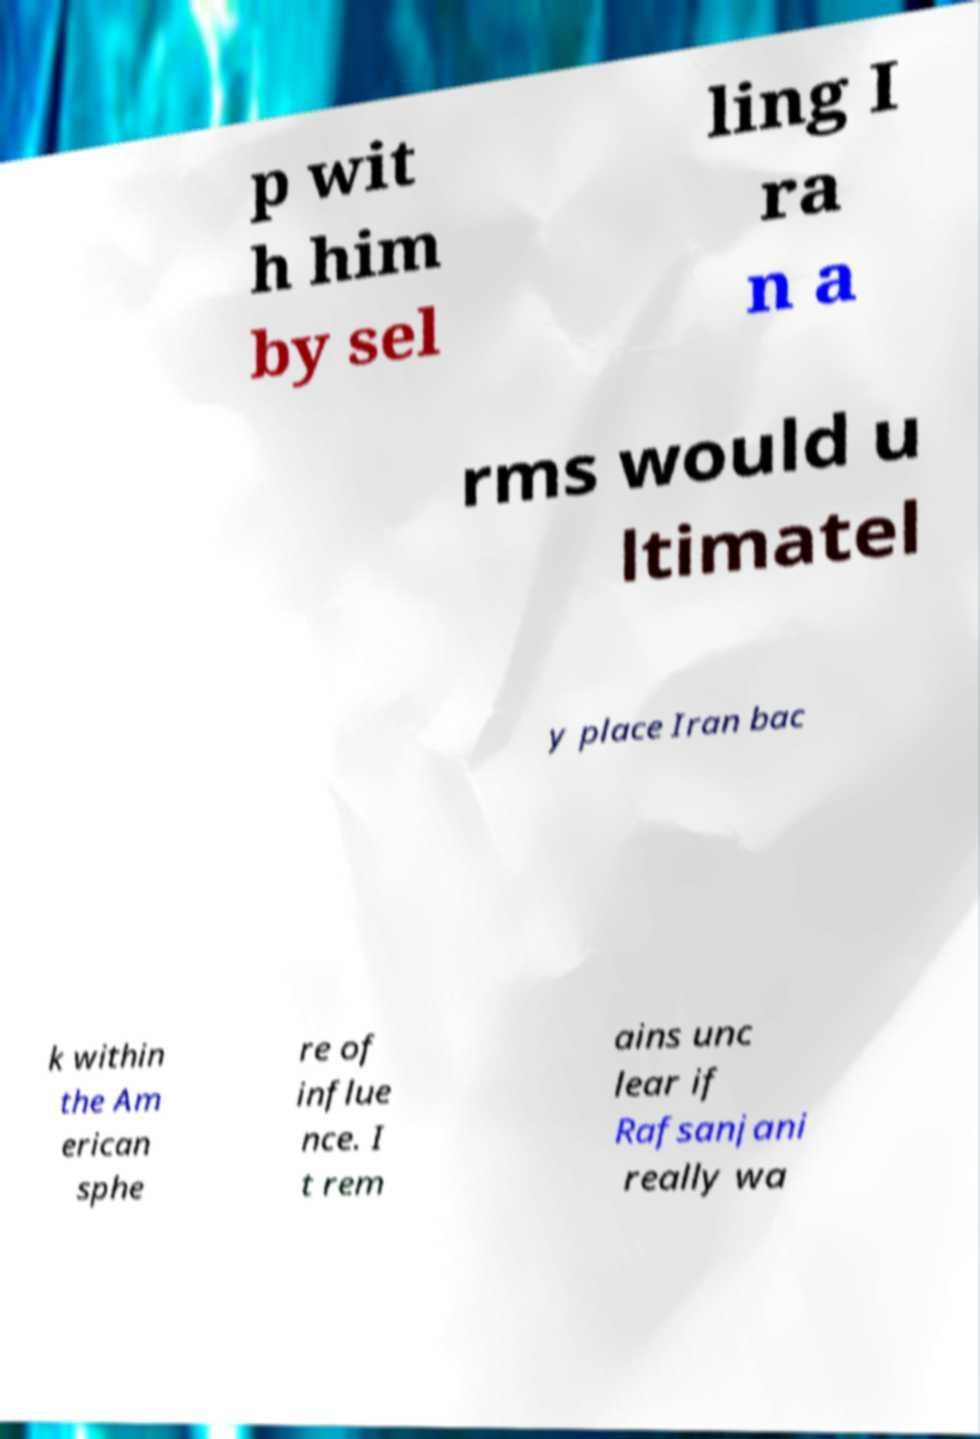Can you read and provide the text displayed in the image?This photo seems to have some interesting text. Can you extract and type it out for me? p wit h him by sel ling I ra n a rms would u ltimatel y place Iran bac k within the Am erican sphe re of influe nce. I t rem ains unc lear if Rafsanjani really wa 